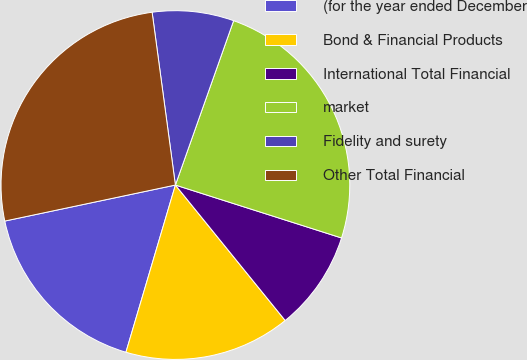Convert chart to OTSL. <chart><loc_0><loc_0><loc_500><loc_500><pie_chart><fcel>(for the year ended December<fcel>Bond & Financial Products<fcel>International Total Financial<fcel>market<fcel>Fidelity and surety<fcel>Other Total Financial<nl><fcel>17.11%<fcel>15.42%<fcel>9.25%<fcel>24.49%<fcel>7.55%<fcel>26.18%<nl></chart> 